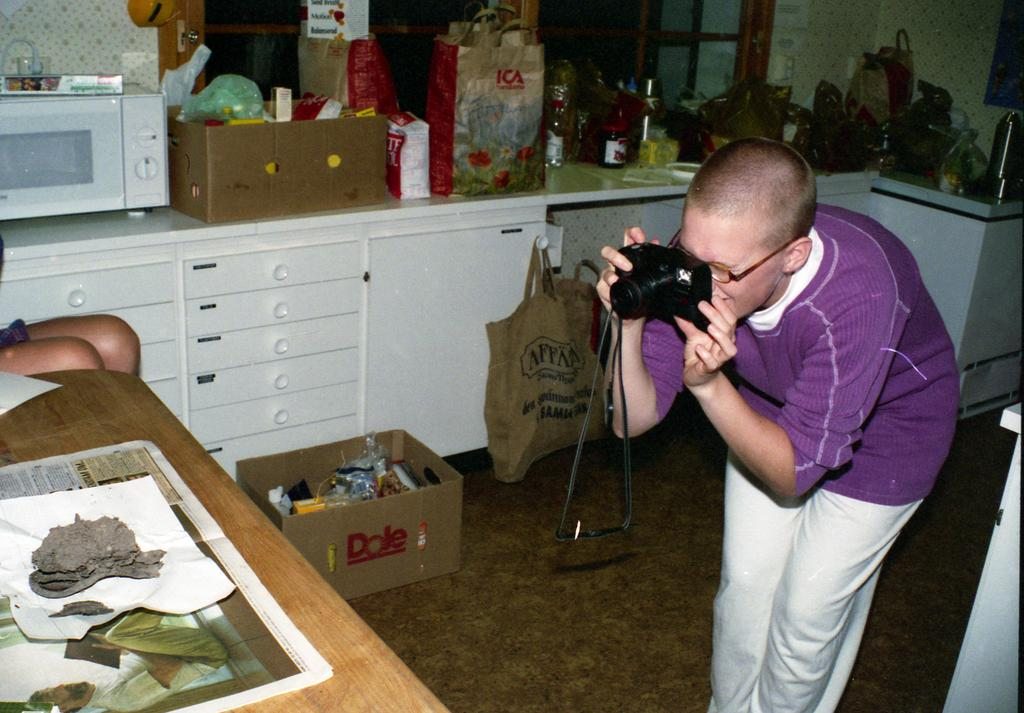Provide a one-sentence caption for the provided image. a Dole box is sitting beside the person who is taking a picture of the table. 